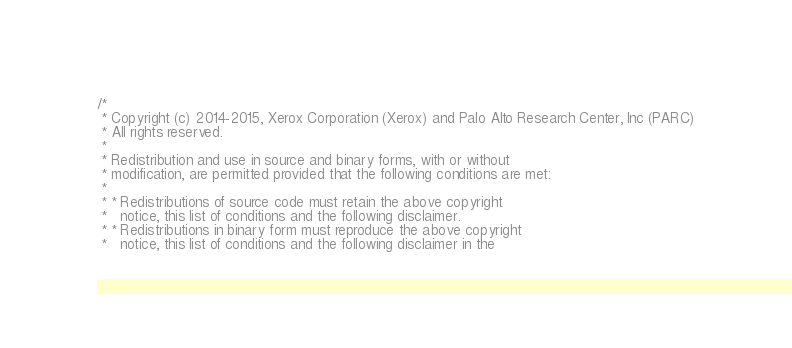<code> <loc_0><loc_0><loc_500><loc_500><_C_>/*
 * Copyright (c) 2014-2015, Xerox Corporation (Xerox) and Palo Alto Research Center, Inc (PARC)
 * All rights reserved.
 *
 * Redistribution and use in source and binary forms, with or without
 * modification, are permitted provided that the following conditions are met:
 *
 * * Redistributions of source code must retain the above copyright
 *   notice, this list of conditions and the following disclaimer.
 * * Redistributions in binary form must reproduce the above copyright
 *   notice, this list of conditions and the following disclaimer in the</code> 